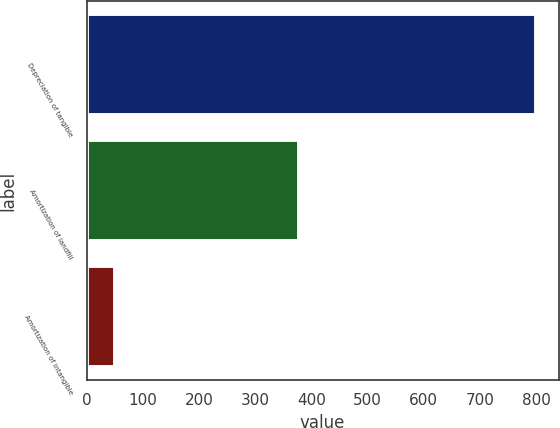Convert chart to OTSL. <chart><loc_0><loc_0><loc_500><loc_500><bar_chart><fcel>Depreciation of tangible<fcel>Amortization of landfill<fcel>Amortization of intangible<nl><fcel>800<fcel>378<fcel>51<nl></chart> 